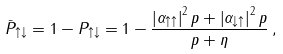Convert formula to latex. <formula><loc_0><loc_0><loc_500><loc_500>\bar { P } _ { \uparrow \downarrow } = 1 - P _ { \uparrow \downarrow } = 1 - \frac { \left | \alpha _ { \uparrow \uparrow } \right | ^ { 2 } p + \left | \alpha _ { \downarrow \uparrow } \right | ^ { 2 } p } { p + \eta } \, ,</formula> 